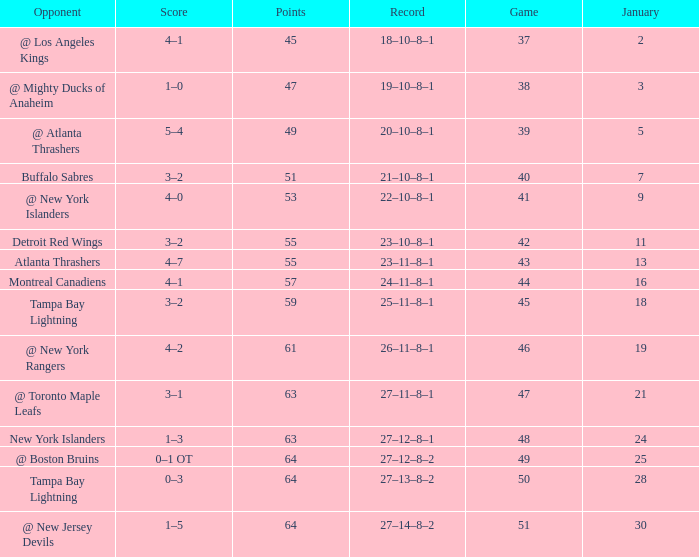How many Points have a January of 18? 1.0. 